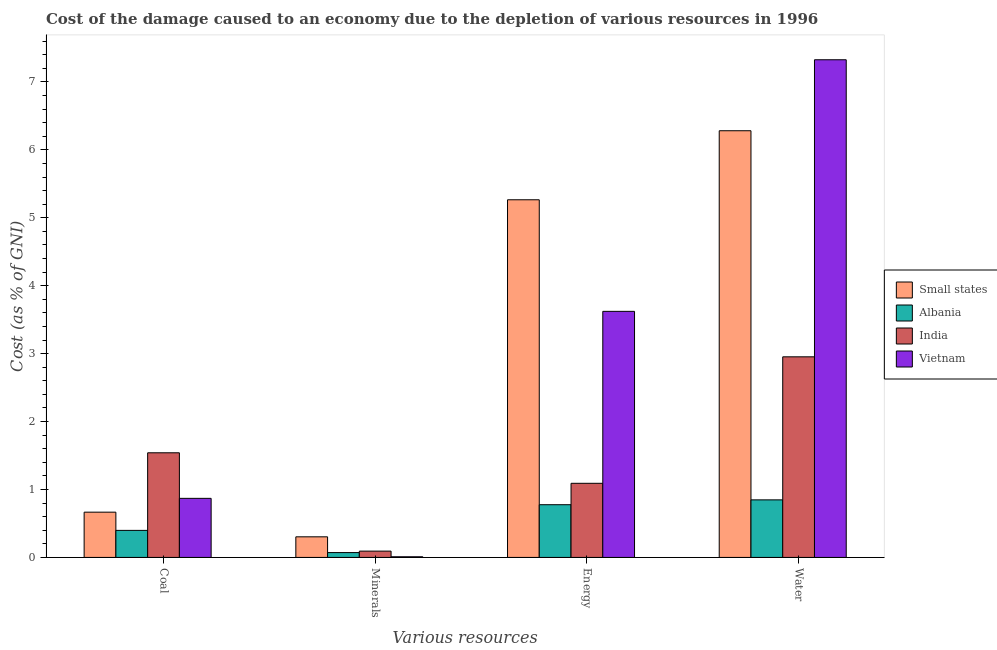How many different coloured bars are there?
Make the answer very short. 4. Are the number of bars per tick equal to the number of legend labels?
Make the answer very short. Yes. What is the label of the 1st group of bars from the left?
Keep it short and to the point. Coal. What is the cost of damage due to depletion of energy in Albania?
Keep it short and to the point. 0.78. Across all countries, what is the maximum cost of damage due to depletion of coal?
Give a very brief answer. 1.54. Across all countries, what is the minimum cost of damage due to depletion of minerals?
Ensure brevity in your answer.  0.01. In which country was the cost of damage due to depletion of minerals maximum?
Offer a terse response. Small states. In which country was the cost of damage due to depletion of energy minimum?
Give a very brief answer. Albania. What is the total cost of damage due to depletion of minerals in the graph?
Make the answer very short. 0.48. What is the difference between the cost of damage due to depletion of energy in Small states and that in India?
Provide a succinct answer. 4.17. What is the difference between the cost of damage due to depletion of coal in Albania and the cost of damage due to depletion of minerals in Small states?
Offer a very short reply. 0.09. What is the average cost of damage due to depletion of minerals per country?
Offer a terse response. 0.12. What is the difference between the cost of damage due to depletion of energy and cost of damage due to depletion of water in Vietnam?
Keep it short and to the point. -3.7. In how many countries, is the cost of damage due to depletion of minerals greater than 6 %?
Offer a very short reply. 0. What is the ratio of the cost of damage due to depletion of energy in India to that in Albania?
Make the answer very short. 1.41. Is the difference between the cost of damage due to depletion of minerals in Vietnam and Small states greater than the difference between the cost of damage due to depletion of water in Vietnam and Small states?
Ensure brevity in your answer.  No. What is the difference between the highest and the second highest cost of damage due to depletion of coal?
Offer a terse response. 0.67. What is the difference between the highest and the lowest cost of damage due to depletion of water?
Provide a succinct answer. 6.48. In how many countries, is the cost of damage due to depletion of minerals greater than the average cost of damage due to depletion of minerals taken over all countries?
Ensure brevity in your answer.  1. Is it the case that in every country, the sum of the cost of damage due to depletion of water and cost of damage due to depletion of energy is greater than the sum of cost of damage due to depletion of coal and cost of damage due to depletion of minerals?
Your answer should be compact. No. What does the 3rd bar from the right in Coal represents?
Your response must be concise. Albania. How many bars are there?
Give a very brief answer. 16. What is the difference between two consecutive major ticks on the Y-axis?
Your response must be concise. 1. Are the values on the major ticks of Y-axis written in scientific E-notation?
Your answer should be very brief. No. Where does the legend appear in the graph?
Ensure brevity in your answer.  Center right. How are the legend labels stacked?
Provide a short and direct response. Vertical. What is the title of the graph?
Give a very brief answer. Cost of the damage caused to an economy due to the depletion of various resources in 1996 . What is the label or title of the X-axis?
Keep it short and to the point. Various resources. What is the label or title of the Y-axis?
Offer a terse response. Cost (as % of GNI). What is the Cost (as % of GNI) of Small states in Coal?
Keep it short and to the point. 0.67. What is the Cost (as % of GNI) of Albania in Coal?
Your answer should be very brief. 0.4. What is the Cost (as % of GNI) in India in Coal?
Ensure brevity in your answer.  1.54. What is the Cost (as % of GNI) in Vietnam in Coal?
Provide a succinct answer. 0.87. What is the Cost (as % of GNI) of Small states in Minerals?
Your response must be concise. 0.3. What is the Cost (as % of GNI) of Albania in Minerals?
Your answer should be very brief. 0.07. What is the Cost (as % of GNI) of India in Minerals?
Make the answer very short. 0.09. What is the Cost (as % of GNI) of Vietnam in Minerals?
Offer a very short reply. 0.01. What is the Cost (as % of GNI) in Small states in Energy?
Give a very brief answer. 5.27. What is the Cost (as % of GNI) of Albania in Energy?
Ensure brevity in your answer.  0.78. What is the Cost (as % of GNI) of India in Energy?
Your response must be concise. 1.09. What is the Cost (as % of GNI) of Vietnam in Energy?
Provide a succinct answer. 3.62. What is the Cost (as % of GNI) in Small states in Water?
Give a very brief answer. 6.28. What is the Cost (as % of GNI) in Albania in Water?
Make the answer very short. 0.85. What is the Cost (as % of GNI) of India in Water?
Keep it short and to the point. 2.95. What is the Cost (as % of GNI) in Vietnam in Water?
Give a very brief answer. 7.33. Across all Various resources, what is the maximum Cost (as % of GNI) of Small states?
Provide a succinct answer. 6.28. Across all Various resources, what is the maximum Cost (as % of GNI) in Albania?
Keep it short and to the point. 0.85. Across all Various resources, what is the maximum Cost (as % of GNI) of India?
Make the answer very short. 2.95. Across all Various resources, what is the maximum Cost (as % of GNI) in Vietnam?
Your answer should be very brief. 7.33. Across all Various resources, what is the minimum Cost (as % of GNI) in Small states?
Your answer should be very brief. 0.3. Across all Various resources, what is the minimum Cost (as % of GNI) of Albania?
Make the answer very short. 0.07. Across all Various resources, what is the minimum Cost (as % of GNI) of India?
Offer a very short reply. 0.09. Across all Various resources, what is the minimum Cost (as % of GNI) of Vietnam?
Your answer should be compact. 0.01. What is the total Cost (as % of GNI) of Small states in the graph?
Ensure brevity in your answer.  12.52. What is the total Cost (as % of GNI) in Albania in the graph?
Your answer should be very brief. 2.09. What is the total Cost (as % of GNI) in India in the graph?
Offer a terse response. 5.68. What is the total Cost (as % of GNI) of Vietnam in the graph?
Your answer should be compact. 11.83. What is the difference between the Cost (as % of GNI) in Small states in Coal and that in Minerals?
Provide a succinct answer. 0.36. What is the difference between the Cost (as % of GNI) of Albania in Coal and that in Minerals?
Provide a succinct answer. 0.33. What is the difference between the Cost (as % of GNI) of India in Coal and that in Minerals?
Keep it short and to the point. 1.45. What is the difference between the Cost (as % of GNI) of Vietnam in Coal and that in Minerals?
Give a very brief answer. 0.86. What is the difference between the Cost (as % of GNI) of Small states in Coal and that in Energy?
Your response must be concise. -4.6. What is the difference between the Cost (as % of GNI) in Albania in Coal and that in Energy?
Offer a terse response. -0.38. What is the difference between the Cost (as % of GNI) of India in Coal and that in Energy?
Offer a terse response. 0.45. What is the difference between the Cost (as % of GNI) in Vietnam in Coal and that in Energy?
Make the answer very short. -2.75. What is the difference between the Cost (as % of GNI) in Small states in Coal and that in Water?
Your response must be concise. -5.61. What is the difference between the Cost (as % of GNI) in Albania in Coal and that in Water?
Provide a short and direct response. -0.45. What is the difference between the Cost (as % of GNI) of India in Coal and that in Water?
Provide a short and direct response. -1.41. What is the difference between the Cost (as % of GNI) of Vietnam in Coal and that in Water?
Ensure brevity in your answer.  -6.46. What is the difference between the Cost (as % of GNI) of Small states in Minerals and that in Energy?
Offer a terse response. -4.96. What is the difference between the Cost (as % of GNI) of Albania in Minerals and that in Energy?
Your answer should be very brief. -0.7. What is the difference between the Cost (as % of GNI) in India in Minerals and that in Energy?
Your answer should be compact. -1. What is the difference between the Cost (as % of GNI) in Vietnam in Minerals and that in Energy?
Provide a short and direct response. -3.61. What is the difference between the Cost (as % of GNI) of Small states in Minerals and that in Water?
Offer a very short reply. -5.98. What is the difference between the Cost (as % of GNI) of Albania in Minerals and that in Water?
Your answer should be very brief. -0.78. What is the difference between the Cost (as % of GNI) in India in Minerals and that in Water?
Give a very brief answer. -2.86. What is the difference between the Cost (as % of GNI) of Vietnam in Minerals and that in Water?
Your answer should be very brief. -7.32. What is the difference between the Cost (as % of GNI) in Small states in Energy and that in Water?
Ensure brevity in your answer.  -1.02. What is the difference between the Cost (as % of GNI) in Albania in Energy and that in Water?
Provide a succinct answer. -0.07. What is the difference between the Cost (as % of GNI) of India in Energy and that in Water?
Keep it short and to the point. -1.86. What is the difference between the Cost (as % of GNI) in Vietnam in Energy and that in Water?
Your response must be concise. -3.7. What is the difference between the Cost (as % of GNI) of Small states in Coal and the Cost (as % of GNI) of Albania in Minerals?
Offer a very short reply. 0.6. What is the difference between the Cost (as % of GNI) of Small states in Coal and the Cost (as % of GNI) of India in Minerals?
Keep it short and to the point. 0.57. What is the difference between the Cost (as % of GNI) of Small states in Coal and the Cost (as % of GNI) of Vietnam in Minerals?
Provide a short and direct response. 0.66. What is the difference between the Cost (as % of GNI) of Albania in Coal and the Cost (as % of GNI) of India in Minerals?
Make the answer very short. 0.31. What is the difference between the Cost (as % of GNI) in Albania in Coal and the Cost (as % of GNI) in Vietnam in Minerals?
Keep it short and to the point. 0.39. What is the difference between the Cost (as % of GNI) of India in Coal and the Cost (as % of GNI) of Vietnam in Minerals?
Provide a short and direct response. 1.53. What is the difference between the Cost (as % of GNI) in Small states in Coal and the Cost (as % of GNI) in Albania in Energy?
Make the answer very short. -0.11. What is the difference between the Cost (as % of GNI) of Small states in Coal and the Cost (as % of GNI) of India in Energy?
Make the answer very short. -0.42. What is the difference between the Cost (as % of GNI) in Small states in Coal and the Cost (as % of GNI) in Vietnam in Energy?
Ensure brevity in your answer.  -2.96. What is the difference between the Cost (as % of GNI) in Albania in Coal and the Cost (as % of GNI) in India in Energy?
Provide a short and direct response. -0.69. What is the difference between the Cost (as % of GNI) of Albania in Coal and the Cost (as % of GNI) of Vietnam in Energy?
Give a very brief answer. -3.22. What is the difference between the Cost (as % of GNI) in India in Coal and the Cost (as % of GNI) in Vietnam in Energy?
Offer a terse response. -2.08. What is the difference between the Cost (as % of GNI) of Small states in Coal and the Cost (as % of GNI) of Albania in Water?
Offer a very short reply. -0.18. What is the difference between the Cost (as % of GNI) of Small states in Coal and the Cost (as % of GNI) of India in Water?
Offer a terse response. -2.29. What is the difference between the Cost (as % of GNI) of Small states in Coal and the Cost (as % of GNI) of Vietnam in Water?
Offer a very short reply. -6.66. What is the difference between the Cost (as % of GNI) in Albania in Coal and the Cost (as % of GNI) in India in Water?
Offer a terse response. -2.56. What is the difference between the Cost (as % of GNI) of Albania in Coal and the Cost (as % of GNI) of Vietnam in Water?
Provide a succinct answer. -6.93. What is the difference between the Cost (as % of GNI) in India in Coal and the Cost (as % of GNI) in Vietnam in Water?
Give a very brief answer. -5.79. What is the difference between the Cost (as % of GNI) in Small states in Minerals and the Cost (as % of GNI) in Albania in Energy?
Your answer should be compact. -0.47. What is the difference between the Cost (as % of GNI) in Small states in Minerals and the Cost (as % of GNI) in India in Energy?
Ensure brevity in your answer.  -0.79. What is the difference between the Cost (as % of GNI) in Small states in Minerals and the Cost (as % of GNI) in Vietnam in Energy?
Ensure brevity in your answer.  -3.32. What is the difference between the Cost (as % of GNI) in Albania in Minerals and the Cost (as % of GNI) in India in Energy?
Your answer should be compact. -1.02. What is the difference between the Cost (as % of GNI) in Albania in Minerals and the Cost (as % of GNI) in Vietnam in Energy?
Provide a short and direct response. -3.55. What is the difference between the Cost (as % of GNI) of India in Minerals and the Cost (as % of GNI) of Vietnam in Energy?
Your answer should be compact. -3.53. What is the difference between the Cost (as % of GNI) in Small states in Minerals and the Cost (as % of GNI) in Albania in Water?
Your answer should be very brief. -0.54. What is the difference between the Cost (as % of GNI) of Small states in Minerals and the Cost (as % of GNI) of India in Water?
Give a very brief answer. -2.65. What is the difference between the Cost (as % of GNI) in Small states in Minerals and the Cost (as % of GNI) in Vietnam in Water?
Give a very brief answer. -7.02. What is the difference between the Cost (as % of GNI) in Albania in Minerals and the Cost (as % of GNI) in India in Water?
Give a very brief answer. -2.88. What is the difference between the Cost (as % of GNI) in Albania in Minerals and the Cost (as % of GNI) in Vietnam in Water?
Offer a very short reply. -7.25. What is the difference between the Cost (as % of GNI) in India in Minerals and the Cost (as % of GNI) in Vietnam in Water?
Offer a very short reply. -7.23. What is the difference between the Cost (as % of GNI) in Small states in Energy and the Cost (as % of GNI) in Albania in Water?
Offer a terse response. 4.42. What is the difference between the Cost (as % of GNI) in Small states in Energy and the Cost (as % of GNI) in India in Water?
Your answer should be compact. 2.31. What is the difference between the Cost (as % of GNI) in Small states in Energy and the Cost (as % of GNI) in Vietnam in Water?
Keep it short and to the point. -2.06. What is the difference between the Cost (as % of GNI) in Albania in Energy and the Cost (as % of GNI) in India in Water?
Offer a very short reply. -2.18. What is the difference between the Cost (as % of GNI) of Albania in Energy and the Cost (as % of GNI) of Vietnam in Water?
Provide a short and direct response. -6.55. What is the difference between the Cost (as % of GNI) in India in Energy and the Cost (as % of GNI) in Vietnam in Water?
Offer a very short reply. -6.23. What is the average Cost (as % of GNI) in Small states per Various resources?
Give a very brief answer. 3.13. What is the average Cost (as % of GNI) of Albania per Various resources?
Your answer should be very brief. 0.52. What is the average Cost (as % of GNI) of India per Various resources?
Ensure brevity in your answer.  1.42. What is the average Cost (as % of GNI) in Vietnam per Various resources?
Offer a very short reply. 2.96. What is the difference between the Cost (as % of GNI) in Small states and Cost (as % of GNI) in Albania in Coal?
Ensure brevity in your answer.  0.27. What is the difference between the Cost (as % of GNI) of Small states and Cost (as % of GNI) of India in Coal?
Offer a very short reply. -0.87. What is the difference between the Cost (as % of GNI) of Small states and Cost (as % of GNI) of Vietnam in Coal?
Offer a terse response. -0.2. What is the difference between the Cost (as % of GNI) of Albania and Cost (as % of GNI) of India in Coal?
Offer a very short reply. -1.14. What is the difference between the Cost (as % of GNI) of Albania and Cost (as % of GNI) of Vietnam in Coal?
Offer a terse response. -0.47. What is the difference between the Cost (as % of GNI) in India and Cost (as % of GNI) in Vietnam in Coal?
Provide a succinct answer. 0.67. What is the difference between the Cost (as % of GNI) in Small states and Cost (as % of GNI) in Albania in Minerals?
Provide a succinct answer. 0.23. What is the difference between the Cost (as % of GNI) of Small states and Cost (as % of GNI) of India in Minerals?
Make the answer very short. 0.21. What is the difference between the Cost (as % of GNI) of Small states and Cost (as % of GNI) of Vietnam in Minerals?
Your answer should be very brief. 0.29. What is the difference between the Cost (as % of GNI) in Albania and Cost (as % of GNI) in India in Minerals?
Offer a terse response. -0.02. What is the difference between the Cost (as % of GNI) of Albania and Cost (as % of GNI) of Vietnam in Minerals?
Your response must be concise. 0.06. What is the difference between the Cost (as % of GNI) in India and Cost (as % of GNI) in Vietnam in Minerals?
Keep it short and to the point. 0.08. What is the difference between the Cost (as % of GNI) in Small states and Cost (as % of GNI) in Albania in Energy?
Ensure brevity in your answer.  4.49. What is the difference between the Cost (as % of GNI) of Small states and Cost (as % of GNI) of India in Energy?
Provide a short and direct response. 4.17. What is the difference between the Cost (as % of GNI) of Small states and Cost (as % of GNI) of Vietnam in Energy?
Ensure brevity in your answer.  1.64. What is the difference between the Cost (as % of GNI) of Albania and Cost (as % of GNI) of India in Energy?
Your answer should be very brief. -0.32. What is the difference between the Cost (as % of GNI) of Albania and Cost (as % of GNI) of Vietnam in Energy?
Your response must be concise. -2.85. What is the difference between the Cost (as % of GNI) of India and Cost (as % of GNI) of Vietnam in Energy?
Give a very brief answer. -2.53. What is the difference between the Cost (as % of GNI) in Small states and Cost (as % of GNI) in Albania in Water?
Ensure brevity in your answer.  5.43. What is the difference between the Cost (as % of GNI) of Small states and Cost (as % of GNI) of India in Water?
Ensure brevity in your answer.  3.33. What is the difference between the Cost (as % of GNI) in Small states and Cost (as % of GNI) in Vietnam in Water?
Make the answer very short. -1.04. What is the difference between the Cost (as % of GNI) in Albania and Cost (as % of GNI) in India in Water?
Keep it short and to the point. -2.11. What is the difference between the Cost (as % of GNI) in Albania and Cost (as % of GNI) in Vietnam in Water?
Your answer should be compact. -6.48. What is the difference between the Cost (as % of GNI) of India and Cost (as % of GNI) of Vietnam in Water?
Your answer should be compact. -4.37. What is the ratio of the Cost (as % of GNI) of Small states in Coal to that in Minerals?
Your answer should be very brief. 2.2. What is the ratio of the Cost (as % of GNI) of Albania in Coal to that in Minerals?
Your response must be concise. 5.59. What is the ratio of the Cost (as % of GNI) in India in Coal to that in Minerals?
Offer a very short reply. 16.57. What is the ratio of the Cost (as % of GNI) in Vietnam in Coal to that in Minerals?
Ensure brevity in your answer.  89.72. What is the ratio of the Cost (as % of GNI) of Small states in Coal to that in Energy?
Give a very brief answer. 0.13. What is the ratio of the Cost (as % of GNI) of Albania in Coal to that in Energy?
Offer a very short reply. 0.51. What is the ratio of the Cost (as % of GNI) in India in Coal to that in Energy?
Keep it short and to the point. 1.41. What is the ratio of the Cost (as % of GNI) of Vietnam in Coal to that in Energy?
Keep it short and to the point. 0.24. What is the ratio of the Cost (as % of GNI) of Small states in Coal to that in Water?
Offer a terse response. 0.11. What is the ratio of the Cost (as % of GNI) of Albania in Coal to that in Water?
Offer a terse response. 0.47. What is the ratio of the Cost (as % of GNI) in India in Coal to that in Water?
Make the answer very short. 0.52. What is the ratio of the Cost (as % of GNI) in Vietnam in Coal to that in Water?
Offer a very short reply. 0.12. What is the ratio of the Cost (as % of GNI) in Small states in Minerals to that in Energy?
Ensure brevity in your answer.  0.06. What is the ratio of the Cost (as % of GNI) in Albania in Minerals to that in Energy?
Make the answer very short. 0.09. What is the ratio of the Cost (as % of GNI) in India in Minerals to that in Energy?
Offer a very short reply. 0.09. What is the ratio of the Cost (as % of GNI) in Vietnam in Minerals to that in Energy?
Ensure brevity in your answer.  0. What is the ratio of the Cost (as % of GNI) of Small states in Minerals to that in Water?
Your answer should be very brief. 0.05. What is the ratio of the Cost (as % of GNI) in Albania in Minerals to that in Water?
Your answer should be very brief. 0.08. What is the ratio of the Cost (as % of GNI) of India in Minerals to that in Water?
Give a very brief answer. 0.03. What is the ratio of the Cost (as % of GNI) in Vietnam in Minerals to that in Water?
Offer a terse response. 0. What is the ratio of the Cost (as % of GNI) in Small states in Energy to that in Water?
Ensure brevity in your answer.  0.84. What is the ratio of the Cost (as % of GNI) of Albania in Energy to that in Water?
Your answer should be compact. 0.92. What is the ratio of the Cost (as % of GNI) of India in Energy to that in Water?
Your answer should be very brief. 0.37. What is the ratio of the Cost (as % of GNI) of Vietnam in Energy to that in Water?
Ensure brevity in your answer.  0.49. What is the difference between the highest and the second highest Cost (as % of GNI) in Small states?
Offer a very short reply. 1.02. What is the difference between the highest and the second highest Cost (as % of GNI) in Albania?
Ensure brevity in your answer.  0.07. What is the difference between the highest and the second highest Cost (as % of GNI) of India?
Make the answer very short. 1.41. What is the difference between the highest and the second highest Cost (as % of GNI) in Vietnam?
Your answer should be compact. 3.7. What is the difference between the highest and the lowest Cost (as % of GNI) in Small states?
Offer a very short reply. 5.98. What is the difference between the highest and the lowest Cost (as % of GNI) in Albania?
Your answer should be compact. 0.78. What is the difference between the highest and the lowest Cost (as % of GNI) in India?
Make the answer very short. 2.86. What is the difference between the highest and the lowest Cost (as % of GNI) in Vietnam?
Make the answer very short. 7.32. 